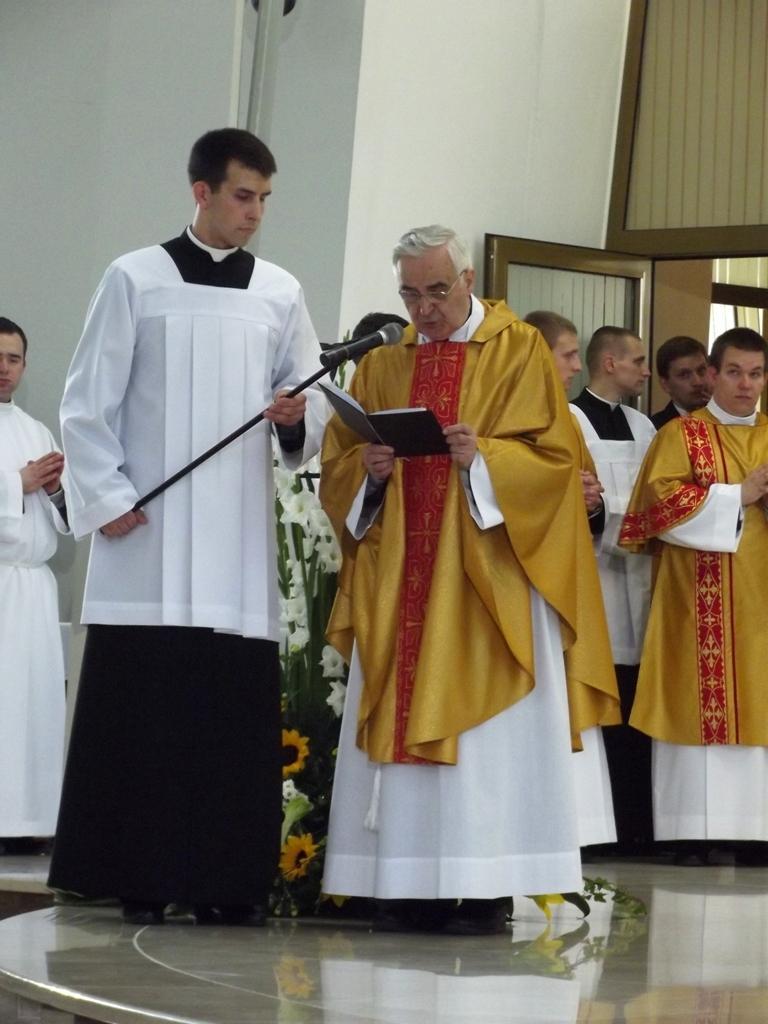In one or two sentences, can you explain what this image depicts? In the middle of the image few people are standing and holding something in their hands. Behind them there are some flowers and plants. Top of the image there is wall and door. 